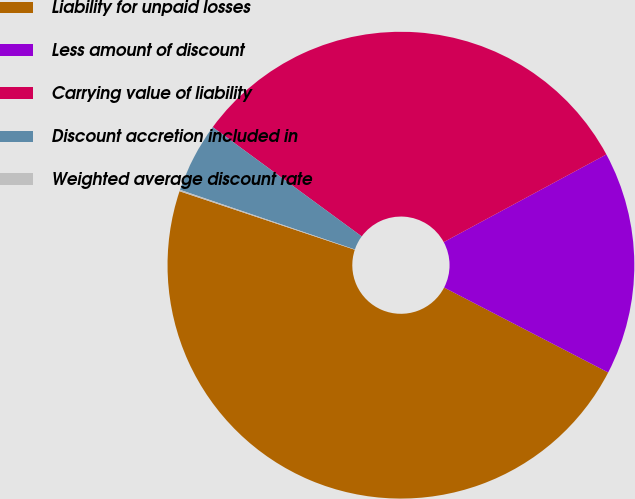Convert chart. <chart><loc_0><loc_0><loc_500><loc_500><pie_chart><fcel>Liability for unpaid losses<fcel>Less amount of discount<fcel>Carrying value of liability<fcel>Discount accretion included in<fcel>Weighted average discount rate<nl><fcel>47.53%<fcel>15.47%<fcel>32.06%<fcel>4.84%<fcel>0.1%<nl></chart> 